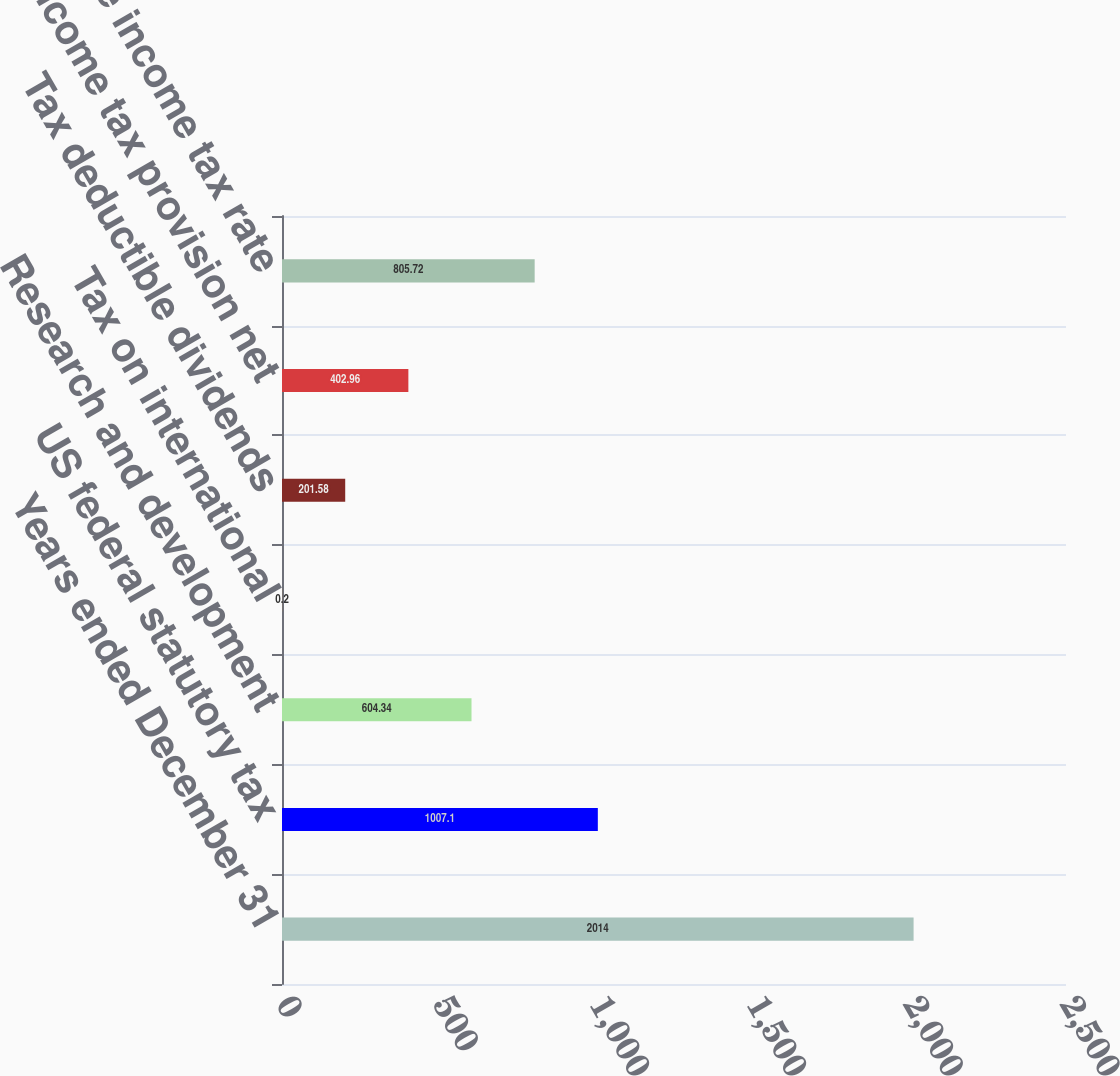<chart> <loc_0><loc_0><loc_500><loc_500><bar_chart><fcel>Years ended December 31<fcel>US federal statutory tax<fcel>Research and development<fcel>Tax on international<fcel>Tax deductible dividends<fcel>State income tax provision net<fcel>Effective income tax rate<nl><fcel>2014<fcel>1007.1<fcel>604.34<fcel>0.2<fcel>201.58<fcel>402.96<fcel>805.72<nl></chart> 